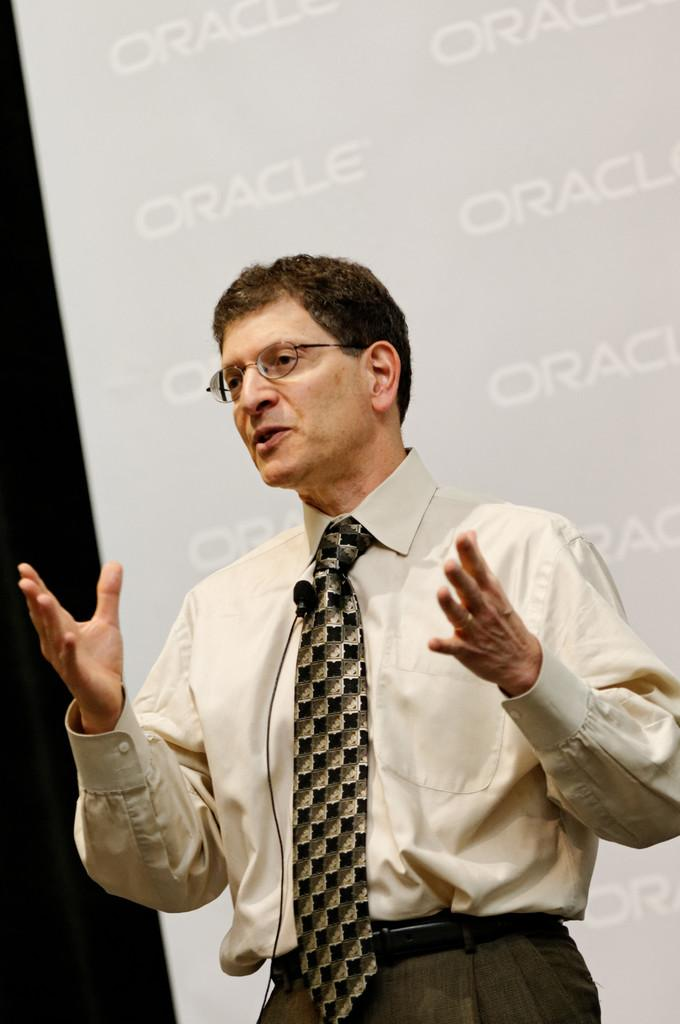Who or what is the main subject of the image? There is a person in the image. What is the person standing in front of? The person is in front of a sponsor board. What can be observed about the person's attire? The person is wearing clothes. Are there any accessories visible on the person? Yes, the person is wearing spectacles. How many icicles are hanging from the person's clothes in the image? There are no icicles present in the image. What type of salt can be seen on the person's spectacles in the image? There is no salt visible on the person's spectacles in the image. 